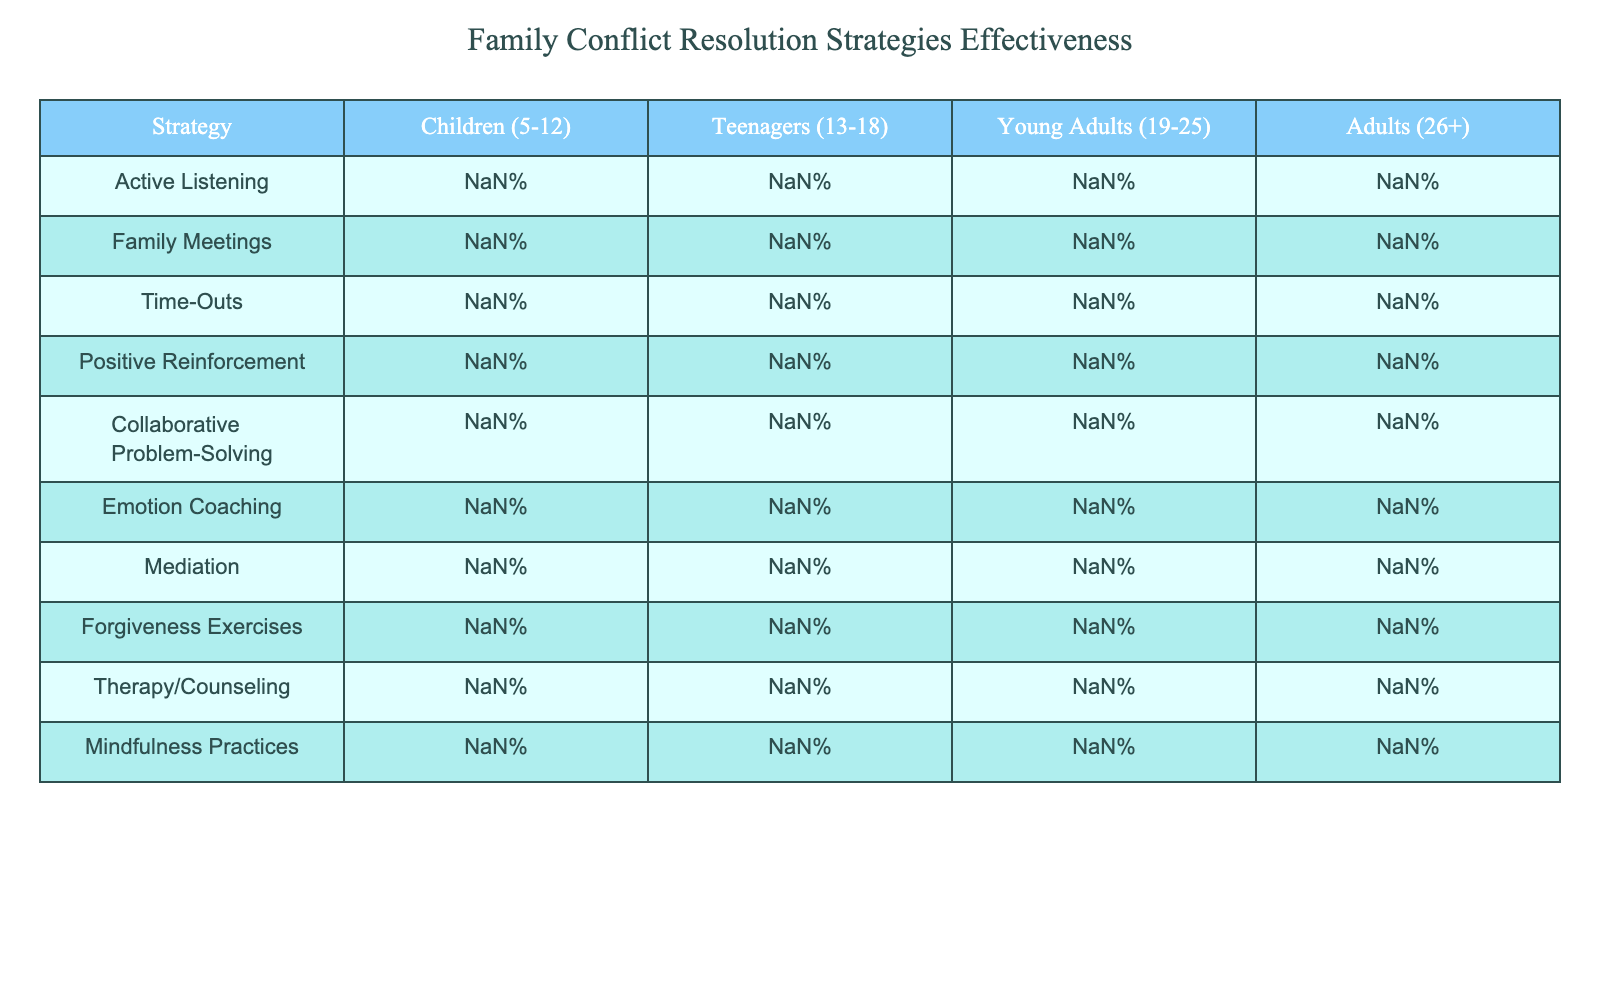What is the effectiveness percentage of Active Listening for teenagers? The table shows that the effectiveness percentage of Active Listening in the Teenagers (13-18) group is 65%.
Answer: 65% Which conflict resolution strategy has the highest effectiveness in the Young Adults (19-25) group? By looking across the Young Adults column, the highest percentage is 90% for Collaborative Problem-Solving.
Answer: Collaborative Problem-Solving What is the difference in effectiveness between Forgiveness Exercises for Children (5-12) and Adults (26+)? The effectiveness percentage for Forgiveness Exercises in the Children (5-12) group is 65%, while for Adults (26+) it's 85%. The difference is 85% - 65% = 20%.
Answer: 20% In which age group is Time-Outs least effective? In the table, the effectiveness percentage for Time-Outs is 20% in the Adults (26+) group, which is lower than the other age groups.
Answer: Adults (26+) Is Positive Reinforcement more effective than Family Meetings for young adults? The table shows that Positive Reinforcement has an effectiveness of 75% for Young Adults, while Family Meetings have 75%. So they are equal, thus Positive Reinforcement is not more effective.
Answer: No What is the average effectiveness percentage for Therapy/Counseling across all age groups? To find the average, sum the percentages: 70% + 75% + 85% + 90% = 320%. There are 4 groups, so the average is 320% / 4 = 80%.
Answer: 80% Which strategy shows the greatest increase in effectiveness from Children (5-12) to Adults (26+)? Looking at the percentages, Mediation goes from 50% for Children (5-12) to 85% for Adults (26+), an increase of 35%. This is the greatest increase.
Answer: Mediation Is Emotion Coaching effective for all age groups above 70%? Checking the table, Emotion Coaching is effective at 80%, 70%, 75%, and 85% for the respective age groups, so it is effective for all groups above 70%.
Answer: Yes What are the top two most effective strategies for Children (5-12)? The table reveals that the top two strategies for Children (5-12) are Positive Reinforcement at 85% and Time-Outs at 80%.
Answer: Positive Reinforcement, Time-Outs Which two strategies are equally effective for Young Adults (19-25)? For Young Adults, both Positive Reinforcement and Family Meetings show an effectiveness of 75%. Thus, they are equally effective strategies.
Answer: Positive Reinforcement, Family Meetings 